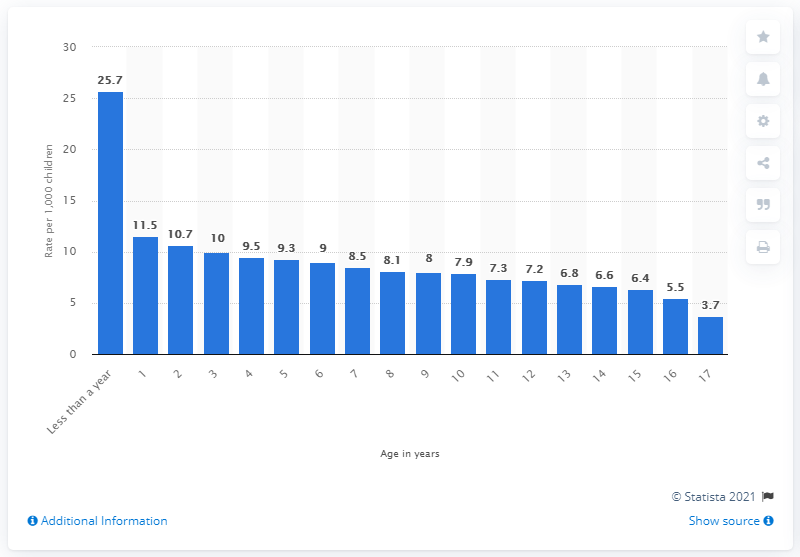Mention a couple of crucial points in this snapshot. In 2019, the rate of child abuse for children under one year old was 25.7%. In 2019, the rate of child abuse for children under the age of one was 25.7%. 